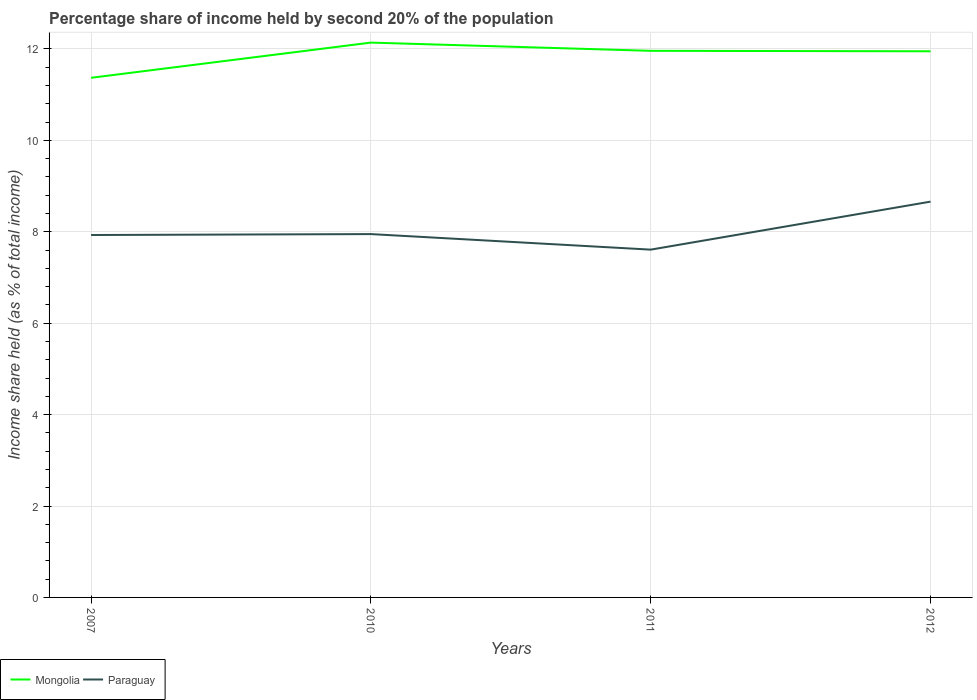Across all years, what is the maximum share of income held by second 20% of the population in Paraguay?
Make the answer very short. 7.61. In which year was the share of income held by second 20% of the population in Mongolia maximum?
Your answer should be compact. 2007. What is the total share of income held by second 20% of the population in Paraguay in the graph?
Offer a very short reply. -0.71. What is the difference between the highest and the second highest share of income held by second 20% of the population in Paraguay?
Ensure brevity in your answer.  1.05. How many years are there in the graph?
Provide a succinct answer. 4. Are the values on the major ticks of Y-axis written in scientific E-notation?
Ensure brevity in your answer.  No. Does the graph contain any zero values?
Your response must be concise. No. How are the legend labels stacked?
Your answer should be very brief. Horizontal. What is the title of the graph?
Your answer should be very brief. Percentage share of income held by second 20% of the population. Does "Bhutan" appear as one of the legend labels in the graph?
Keep it short and to the point. No. What is the label or title of the Y-axis?
Provide a succinct answer. Income share held (as % of total income). What is the Income share held (as % of total income) of Mongolia in 2007?
Give a very brief answer. 11.37. What is the Income share held (as % of total income) of Paraguay in 2007?
Offer a terse response. 7.93. What is the Income share held (as % of total income) in Mongolia in 2010?
Make the answer very short. 12.14. What is the Income share held (as % of total income) in Paraguay in 2010?
Offer a very short reply. 7.95. What is the Income share held (as % of total income) in Mongolia in 2011?
Provide a succinct answer. 11.96. What is the Income share held (as % of total income) of Paraguay in 2011?
Your answer should be very brief. 7.61. What is the Income share held (as % of total income) in Mongolia in 2012?
Keep it short and to the point. 11.95. What is the Income share held (as % of total income) in Paraguay in 2012?
Your answer should be very brief. 8.66. Across all years, what is the maximum Income share held (as % of total income) in Mongolia?
Offer a very short reply. 12.14. Across all years, what is the maximum Income share held (as % of total income) in Paraguay?
Offer a terse response. 8.66. Across all years, what is the minimum Income share held (as % of total income) in Mongolia?
Your response must be concise. 11.37. Across all years, what is the minimum Income share held (as % of total income) of Paraguay?
Make the answer very short. 7.61. What is the total Income share held (as % of total income) in Mongolia in the graph?
Ensure brevity in your answer.  47.42. What is the total Income share held (as % of total income) of Paraguay in the graph?
Keep it short and to the point. 32.15. What is the difference between the Income share held (as % of total income) in Mongolia in 2007 and that in 2010?
Make the answer very short. -0.77. What is the difference between the Income share held (as % of total income) of Paraguay in 2007 and that in 2010?
Keep it short and to the point. -0.02. What is the difference between the Income share held (as % of total income) of Mongolia in 2007 and that in 2011?
Make the answer very short. -0.59. What is the difference between the Income share held (as % of total income) in Paraguay in 2007 and that in 2011?
Ensure brevity in your answer.  0.32. What is the difference between the Income share held (as % of total income) of Mongolia in 2007 and that in 2012?
Keep it short and to the point. -0.58. What is the difference between the Income share held (as % of total income) of Paraguay in 2007 and that in 2012?
Provide a short and direct response. -0.73. What is the difference between the Income share held (as % of total income) in Mongolia in 2010 and that in 2011?
Offer a terse response. 0.18. What is the difference between the Income share held (as % of total income) of Paraguay in 2010 and that in 2011?
Your response must be concise. 0.34. What is the difference between the Income share held (as % of total income) of Mongolia in 2010 and that in 2012?
Provide a short and direct response. 0.19. What is the difference between the Income share held (as % of total income) of Paraguay in 2010 and that in 2012?
Keep it short and to the point. -0.71. What is the difference between the Income share held (as % of total income) of Mongolia in 2011 and that in 2012?
Offer a very short reply. 0.01. What is the difference between the Income share held (as % of total income) of Paraguay in 2011 and that in 2012?
Your answer should be very brief. -1.05. What is the difference between the Income share held (as % of total income) in Mongolia in 2007 and the Income share held (as % of total income) in Paraguay in 2010?
Ensure brevity in your answer.  3.42. What is the difference between the Income share held (as % of total income) in Mongolia in 2007 and the Income share held (as % of total income) in Paraguay in 2011?
Your response must be concise. 3.76. What is the difference between the Income share held (as % of total income) of Mongolia in 2007 and the Income share held (as % of total income) of Paraguay in 2012?
Give a very brief answer. 2.71. What is the difference between the Income share held (as % of total income) in Mongolia in 2010 and the Income share held (as % of total income) in Paraguay in 2011?
Your answer should be compact. 4.53. What is the difference between the Income share held (as % of total income) in Mongolia in 2010 and the Income share held (as % of total income) in Paraguay in 2012?
Provide a succinct answer. 3.48. What is the average Income share held (as % of total income) of Mongolia per year?
Ensure brevity in your answer.  11.86. What is the average Income share held (as % of total income) of Paraguay per year?
Provide a short and direct response. 8.04. In the year 2007, what is the difference between the Income share held (as % of total income) of Mongolia and Income share held (as % of total income) of Paraguay?
Keep it short and to the point. 3.44. In the year 2010, what is the difference between the Income share held (as % of total income) in Mongolia and Income share held (as % of total income) in Paraguay?
Provide a short and direct response. 4.19. In the year 2011, what is the difference between the Income share held (as % of total income) of Mongolia and Income share held (as % of total income) of Paraguay?
Offer a very short reply. 4.35. In the year 2012, what is the difference between the Income share held (as % of total income) of Mongolia and Income share held (as % of total income) of Paraguay?
Offer a very short reply. 3.29. What is the ratio of the Income share held (as % of total income) of Mongolia in 2007 to that in 2010?
Your response must be concise. 0.94. What is the ratio of the Income share held (as % of total income) in Mongolia in 2007 to that in 2011?
Keep it short and to the point. 0.95. What is the ratio of the Income share held (as % of total income) in Paraguay in 2007 to that in 2011?
Provide a short and direct response. 1.04. What is the ratio of the Income share held (as % of total income) in Mongolia in 2007 to that in 2012?
Provide a succinct answer. 0.95. What is the ratio of the Income share held (as % of total income) of Paraguay in 2007 to that in 2012?
Your response must be concise. 0.92. What is the ratio of the Income share held (as % of total income) in Mongolia in 2010 to that in 2011?
Your answer should be compact. 1.02. What is the ratio of the Income share held (as % of total income) in Paraguay in 2010 to that in 2011?
Keep it short and to the point. 1.04. What is the ratio of the Income share held (as % of total income) in Mongolia in 2010 to that in 2012?
Give a very brief answer. 1.02. What is the ratio of the Income share held (as % of total income) in Paraguay in 2010 to that in 2012?
Provide a short and direct response. 0.92. What is the ratio of the Income share held (as % of total income) of Paraguay in 2011 to that in 2012?
Make the answer very short. 0.88. What is the difference between the highest and the second highest Income share held (as % of total income) in Mongolia?
Offer a very short reply. 0.18. What is the difference between the highest and the second highest Income share held (as % of total income) in Paraguay?
Your answer should be very brief. 0.71. What is the difference between the highest and the lowest Income share held (as % of total income) of Mongolia?
Your response must be concise. 0.77. 